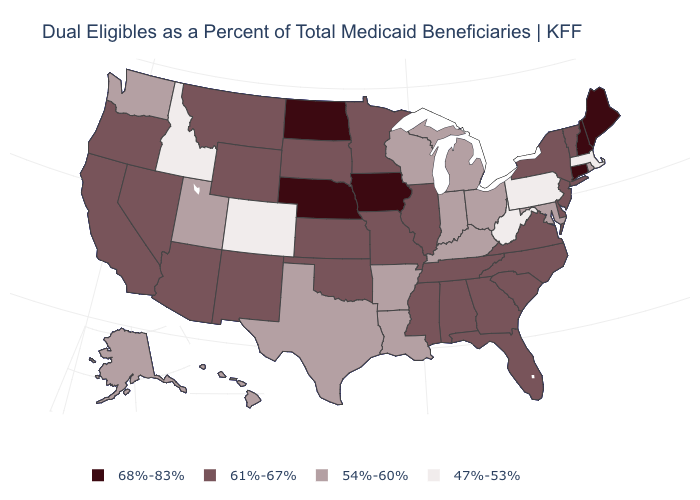What is the value of Connecticut?
Quick response, please. 68%-83%. What is the value of Mississippi?
Quick response, please. 61%-67%. What is the lowest value in the MidWest?
Keep it brief. 54%-60%. Name the states that have a value in the range 54%-60%?
Quick response, please. Alaska, Arkansas, Hawaii, Indiana, Kentucky, Louisiana, Maryland, Michigan, Ohio, Rhode Island, Texas, Utah, Washington, Wisconsin. Does Maine have the highest value in the Northeast?
Short answer required. Yes. Name the states that have a value in the range 68%-83%?
Give a very brief answer. Connecticut, Iowa, Maine, Nebraska, New Hampshire, North Dakota. What is the highest value in states that border Rhode Island?
Concise answer only. 68%-83%. Name the states that have a value in the range 68%-83%?
Give a very brief answer. Connecticut, Iowa, Maine, Nebraska, New Hampshire, North Dakota. What is the value of Wisconsin?
Keep it brief. 54%-60%. What is the highest value in the USA?
Give a very brief answer. 68%-83%. What is the value of Iowa?
Be succinct. 68%-83%. Name the states that have a value in the range 54%-60%?
Short answer required. Alaska, Arkansas, Hawaii, Indiana, Kentucky, Louisiana, Maryland, Michigan, Ohio, Rhode Island, Texas, Utah, Washington, Wisconsin. Does the map have missing data?
Write a very short answer. No. Among the states that border Minnesota , which have the lowest value?
Concise answer only. Wisconsin. Which states have the highest value in the USA?
Answer briefly. Connecticut, Iowa, Maine, Nebraska, New Hampshire, North Dakota. 